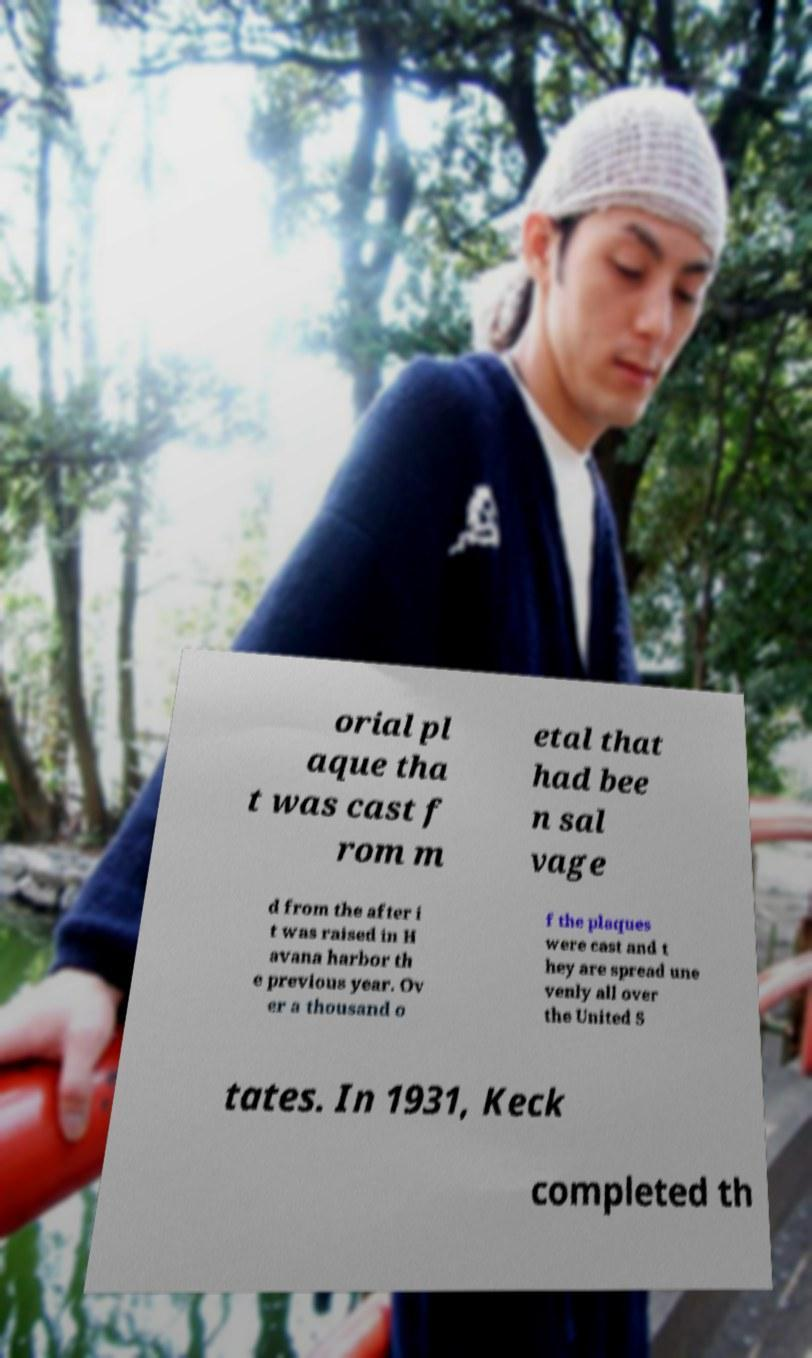There's text embedded in this image that I need extracted. Can you transcribe it verbatim? orial pl aque tha t was cast f rom m etal that had bee n sal vage d from the after i t was raised in H avana harbor th e previous year. Ov er a thousand o f the plaques were cast and t hey are spread une venly all over the United S tates. In 1931, Keck completed th 